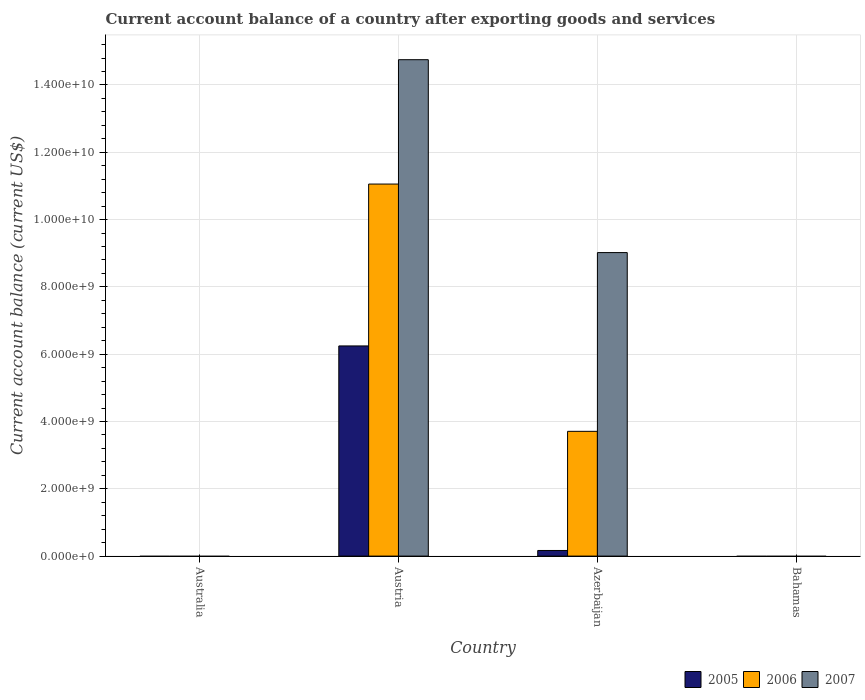How many bars are there on the 3rd tick from the left?
Provide a short and direct response. 3. How many bars are there on the 1st tick from the right?
Offer a terse response. 0. What is the label of the 3rd group of bars from the left?
Your answer should be very brief. Azerbaijan. What is the account balance in 2007 in Australia?
Provide a succinct answer. 0. Across all countries, what is the maximum account balance in 2005?
Offer a terse response. 6.25e+09. What is the total account balance in 2006 in the graph?
Offer a very short reply. 1.48e+1. What is the difference between the account balance in 2007 in Austria and that in Azerbaijan?
Provide a short and direct response. 5.73e+09. What is the difference between the account balance in 2006 in Bahamas and the account balance in 2007 in Australia?
Offer a terse response. 0. What is the average account balance in 2005 per country?
Keep it short and to the point. 1.60e+09. What is the difference between the account balance of/in 2006 and account balance of/in 2005 in Azerbaijan?
Provide a short and direct response. 3.54e+09. Is the difference between the account balance in 2006 in Austria and Azerbaijan greater than the difference between the account balance in 2005 in Austria and Azerbaijan?
Provide a succinct answer. Yes. What is the difference between the highest and the lowest account balance in 2006?
Offer a terse response. 1.11e+1. In how many countries, is the account balance in 2006 greater than the average account balance in 2006 taken over all countries?
Provide a short and direct response. 2. Is it the case that in every country, the sum of the account balance in 2006 and account balance in 2005 is greater than the account balance in 2007?
Your answer should be compact. No. Are all the bars in the graph horizontal?
Your answer should be compact. No. How many countries are there in the graph?
Your response must be concise. 4. Are the values on the major ticks of Y-axis written in scientific E-notation?
Offer a terse response. Yes. Does the graph contain any zero values?
Your answer should be very brief. Yes. Does the graph contain grids?
Give a very brief answer. Yes. What is the title of the graph?
Keep it short and to the point. Current account balance of a country after exporting goods and services. What is the label or title of the X-axis?
Your answer should be compact. Country. What is the label or title of the Y-axis?
Keep it short and to the point. Current account balance (current US$). What is the Current account balance (current US$) of 2006 in Australia?
Give a very brief answer. 0. What is the Current account balance (current US$) of 2005 in Austria?
Give a very brief answer. 6.25e+09. What is the Current account balance (current US$) of 2006 in Austria?
Offer a very short reply. 1.11e+1. What is the Current account balance (current US$) in 2007 in Austria?
Ensure brevity in your answer.  1.48e+1. What is the Current account balance (current US$) of 2005 in Azerbaijan?
Provide a succinct answer. 1.67e+08. What is the Current account balance (current US$) in 2006 in Azerbaijan?
Your answer should be very brief. 3.71e+09. What is the Current account balance (current US$) of 2007 in Azerbaijan?
Provide a short and direct response. 9.02e+09. Across all countries, what is the maximum Current account balance (current US$) of 2005?
Offer a terse response. 6.25e+09. Across all countries, what is the maximum Current account balance (current US$) in 2006?
Provide a succinct answer. 1.11e+1. Across all countries, what is the maximum Current account balance (current US$) of 2007?
Your answer should be compact. 1.48e+1. Across all countries, what is the minimum Current account balance (current US$) in 2005?
Provide a succinct answer. 0. Across all countries, what is the minimum Current account balance (current US$) of 2007?
Provide a succinct answer. 0. What is the total Current account balance (current US$) in 2005 in the graph?
Provide a succinct answer. 6.41e+09. What is the total Current account balance (current US$) of 2006 in the graph?
Your answer should be very brief. 1.48e+1. What is the total Current account balance (current US$) of 2007 in the graph?
Provide a short and direct response. 2.38e+1. What is the difference between the Current account balance (current US$) of 2005 in Austria and that in Azerbaijan?
Offer a terse response. 6.08e+09. What is the difference between the Current account balance (current US$) in 2006 in Austria and that in Azerbaijan?
Give a very brief answer. 7.35e+09. What is the difference between the Current account balance (current US$) of 2007 in Austria and that in Azerbaijan?
Your answer should be compact. 5.73e+09. What is the difference between the Current account balance (current US$) of 2005 in Austria and the Current account balance (current US$) of 2006 in Azerbaijan?
Your answer should be very brief. 2.54e+09. What is the difference between the Current account balance (current US$) in 2005 in Austria and the Current account balance (current US$) in 2007 in Azerbaijan?
Provide a succinct answer. -2.77e+09. What is the difference between the Current account balance (current US$) in 2006 in Austria and the Current account balance (current US$) in 2007 in Azerbaijan?
Provide a short and direct response. 2.04e+09. What is the average Current account balance (current US$) of 2005 per country?
Make the answer very short. 1.60e+09. What is the average Current account balance (current US$) of 2006 per country?
Ensure brevity in your answer.  3.69e+09. What is the average Current account balance (current US$) in 2007 per country?
Make the answer very short. 5.94e+09. What is the difference between the Current account balance (current US$) of 2005 and Current account balance (current US$) of 2006 in Austria?
Offer a terse response. -4.81e+09. What is the difference between the Current account balance (current US$) in 2005 and Current account balance (current US$) in 2007 in Austria?
Your response must be concise. -8.51e+09. What is the difference between the Current account balance (current US$) of 2006 and Current account balance (current US$) of 2007 in Austria?
Ensure brevity in your answer.  -3.70e+09. What is the difference between the Current account balance (current US$) in 2005 and Current account balance (current US$) in 2006 in Azerbaijan?
Make the answer very short. -3.54e+09. What is the difference between the Current account balance (current US$) of 2005 and Current account balance (current US$) of 2007 in Azerbaijan?
Ensure brevity in your answer.  -8.85e+09. What is the difference between the Current account balance (current US$) in 2006 and Current account balance (current US$) in 2007 in Azerbaijan?
Ensure brevity in your answer.  -5.31e+09. What is the ratio of the Current account balance (current US$) of 2005 in Austria to that in Azerbaijan?
Provide a short and direct response. 37.33. What is the ratio of the Current account balance (current US$) in 2006 in Austria to that in Azerbaijan?
Make the answer very short. 2.98. What is the ratio of the Current account balance (current US$) in 2007 in Austria to that in Azerbaijan?
Offer a terse response. 1.64. What is the difference between the highest and the lowest Current account balance (current US$) of 2005?
Your answer should be very brief. 6.25e+09. What is the difference between the highest and the lowest Current account balance (current US$) of 2006?
Provide a short and direct response. 1.11e+1. What is the difference between the highest and the lowest Current account balance (current US$) in 2007?
Offer a very short reply. 1.48e+1. 